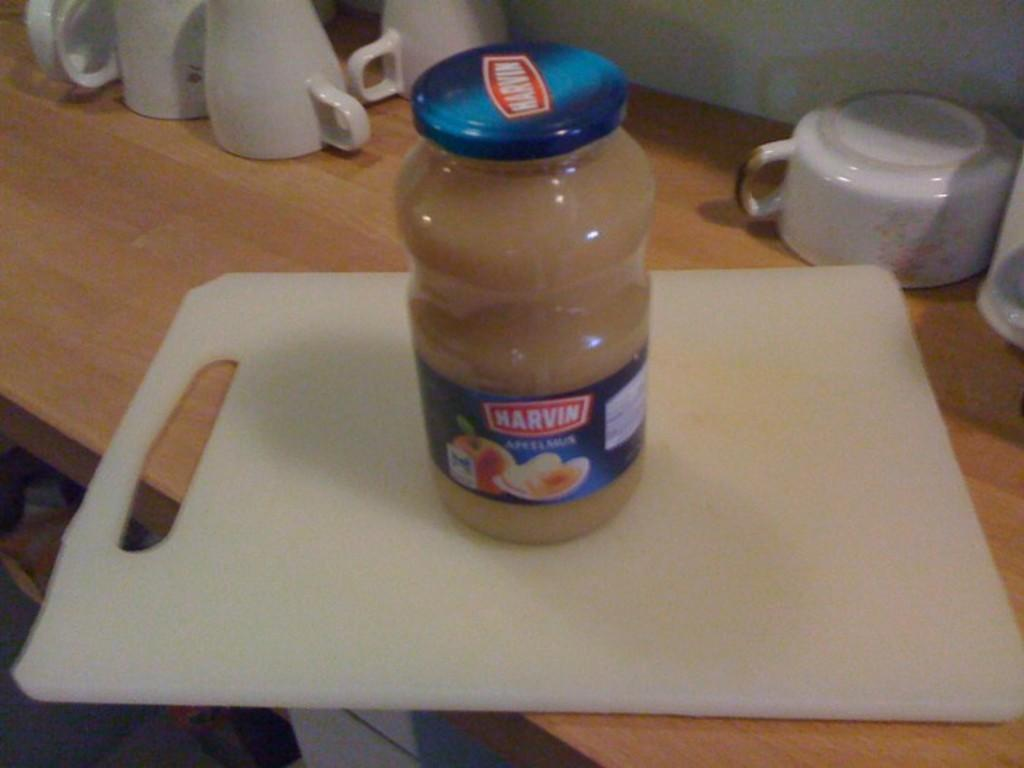<image>
Give a short and clear explanation of the subsequent image. A jar of MArvin applesauce sitting on a white cutting board. 